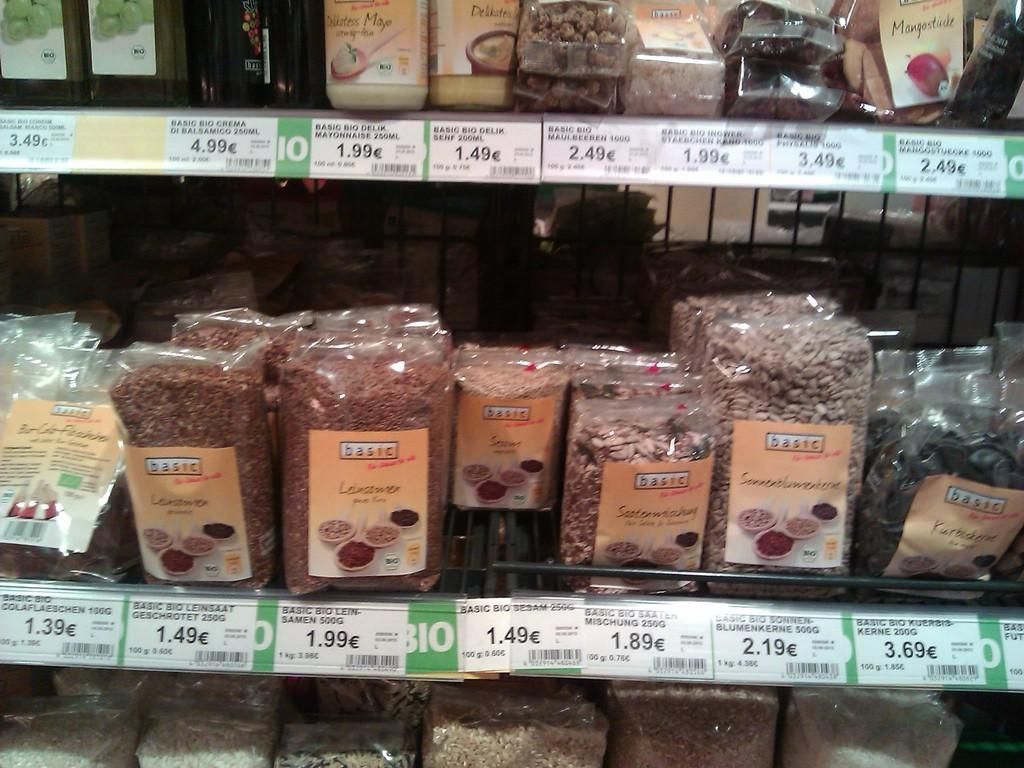<image>
Describe the image concisely. a grocery store isle with basic brand food 